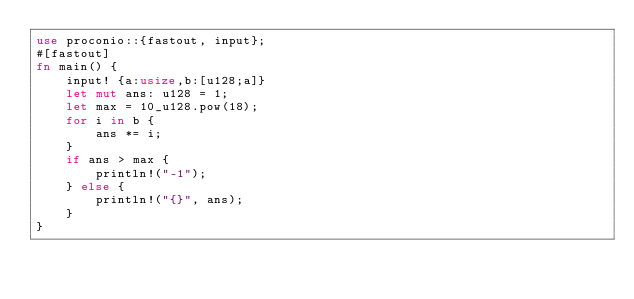<code> <loc_0><loc_0><loc_500><loc_500><_Rust_>use proconio::{fastout, input};
#[fastout]
fn main() {
    input! {a:usize,b:[u128;a]}
    let mut ans: u128 = 1;
    let max = 10_u128.pow(18);
    for i in b {
        ans *= i;
    }
    if ans > max {
        println!("-1");
    } else {
        println!("{}", ans);
    }
}
</code> 